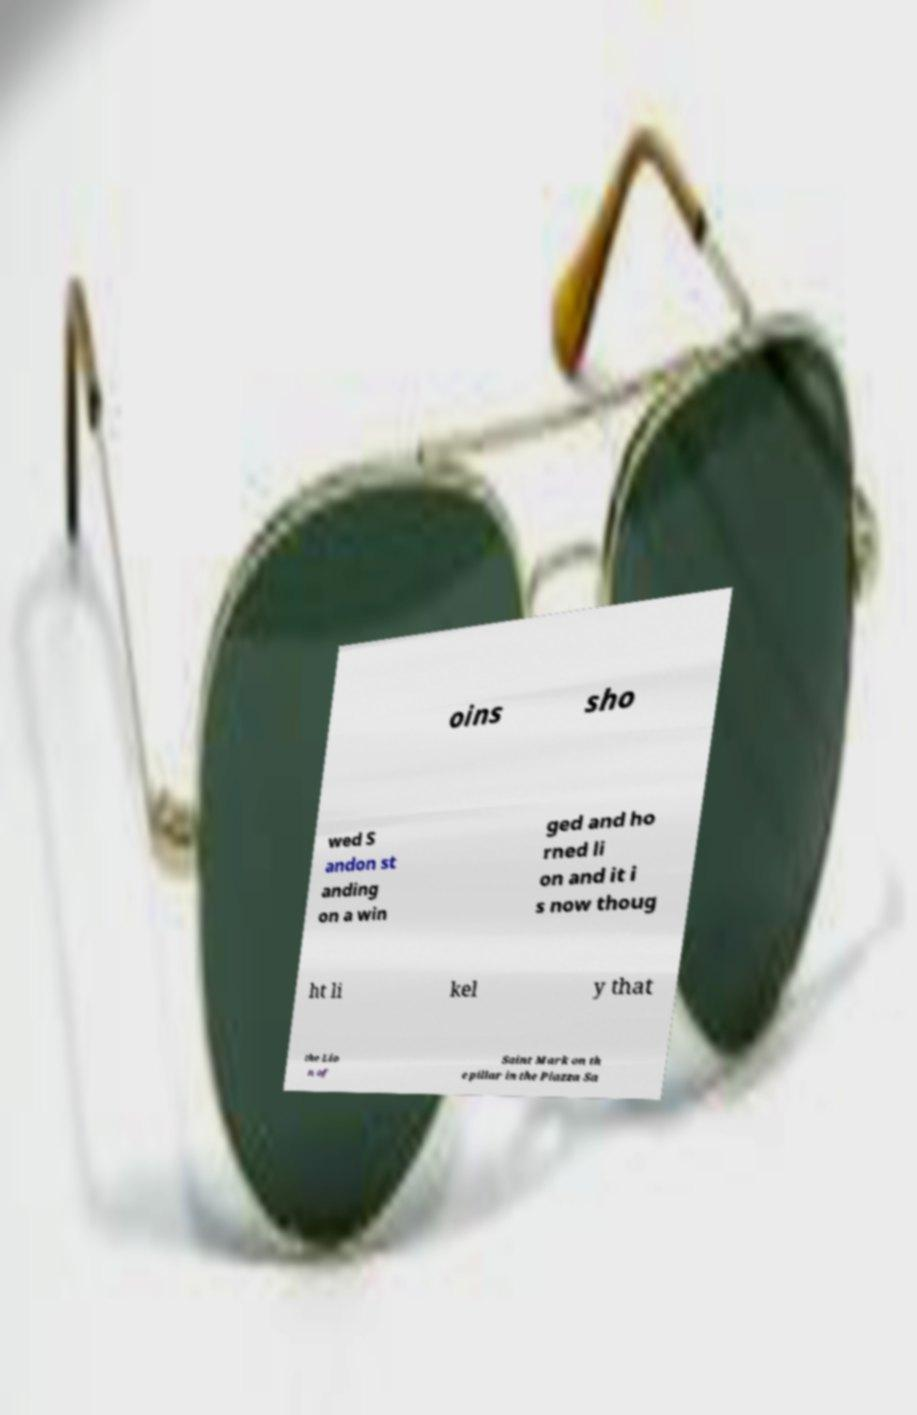I need the written content from this picture converted into text. Can you do that? oins sho wed S andon st anding on a win ged and ho rned li on and it i s now thoug ht li kel y that the Lio n of Saint Mark on th e pillar in the Piazza Sa 